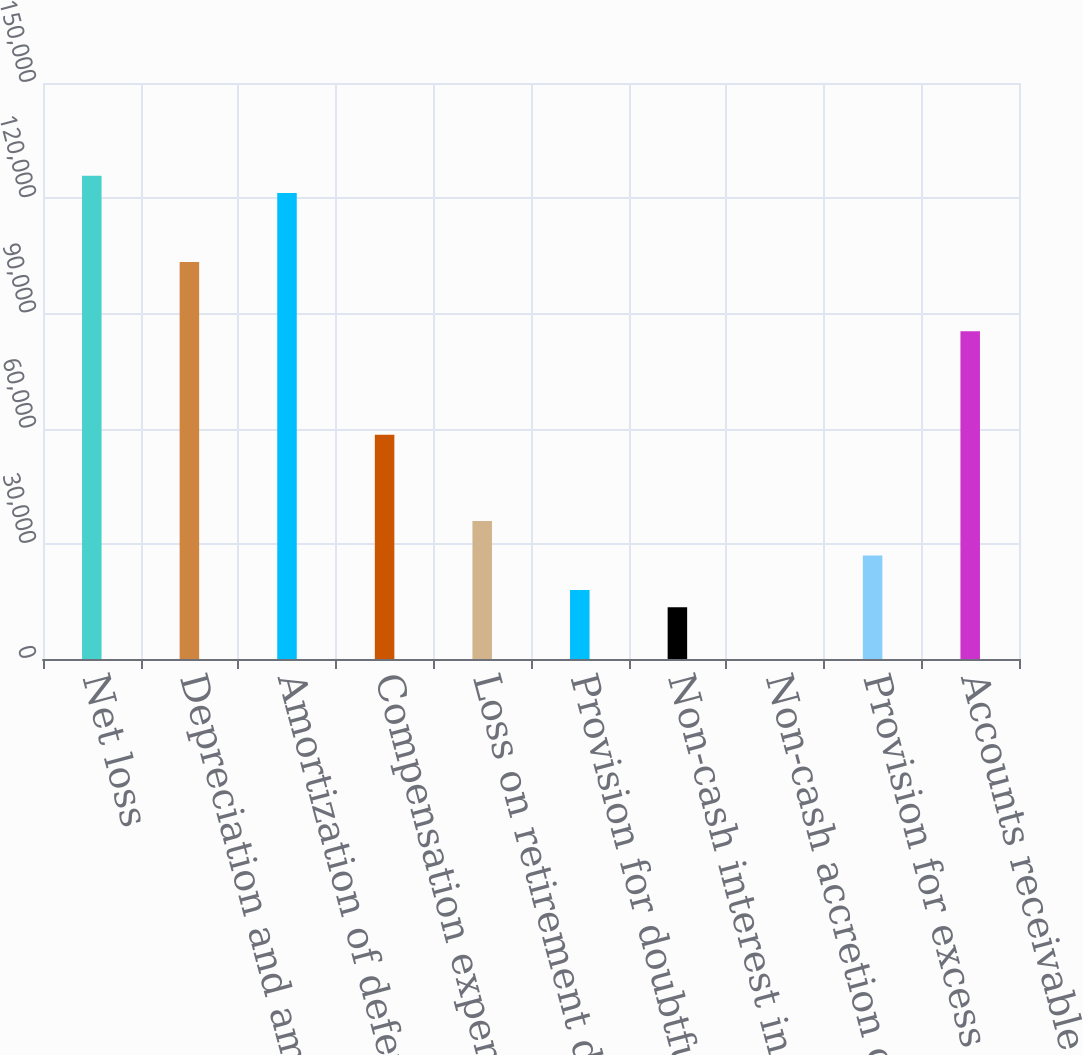Convert chart. <chart><loc_0><loc_0><loc_500><loc_500><bar_chart><fcel>Net loss<fcel>Depreciation and amortization<fcel>Amortization of deferred<fcel>Compensation expense for<fcel>Loss on retirement disposal<fcel>Provision for doubtful<fcel>Non-cash interest income on<fcel>Non-cash accretion on<fcel>Provision for excess and<fcel>Accounts receivable<nl><fcel>125827<fcel>103358<fcel>121334<fcel>58420.4<fcel>35951.4<fcel>17976.2<fcel>13482.4<fcel>1<fcel>26963.8<fcel>85383.2<nl></chart> 